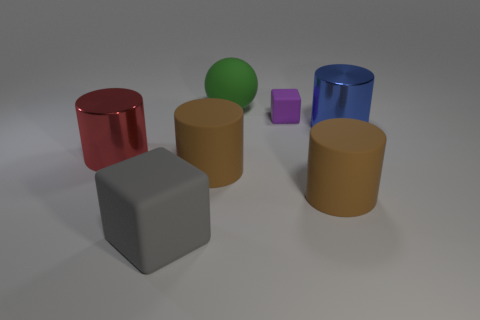Are there any other things that are the same size as the purple matte object?
Keep it short and to the point. No. What number of cubes are right of the big red metallic object?
Give a very brief answer. 2. How many things are either tiny blue matte cylinders or objects right of the large green rubber sphere?
Give a very brief answer. 3. Is there a blue thing in front of the large shiny thing that is on the right side of the large gray rubber object?
Make the answer very short. No. There is a matte block behind the large red cylinder; what color is it?
Provide a succinct answer. Purple. Is the number of big matte spheres on the left side of the gray rubber thing the same as the number of small brown metal cylinders?
Keep it short and to the point. Yes. The large matte object that is both left of the green ball and to the right of the large gray cube has what shape?
Provide a short and direct response. Cylinder. The large matte object that is the same shape as the small purple object is what color?
Your answer should be compact. Gray. Is there any other thing that has the same color as the rubber sphere?
Give a very brief answer. No. The large matte object that is behind the rubber block that is behind the cube in front of the tiny thing is what shape?
Offer a terse response. Sphere. 